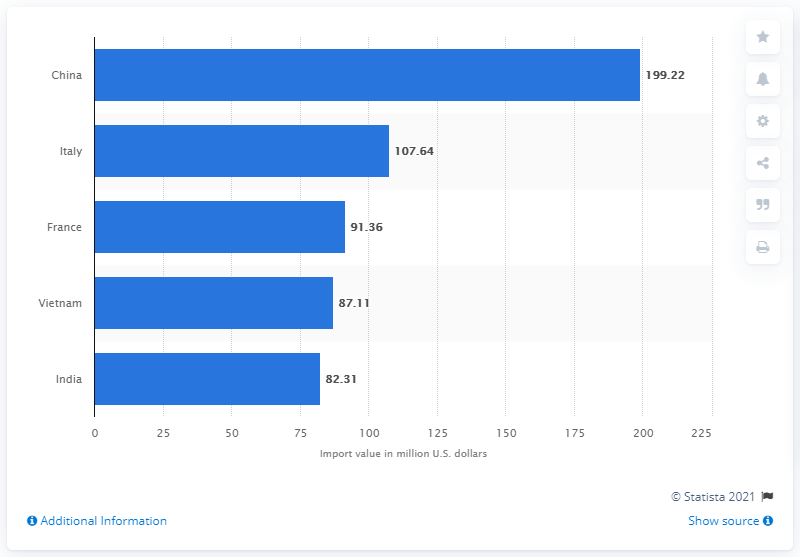List a handful of essential elements in this visual. In 2020, China exported $199.22 billion dollars to the United States. The country that was the leading exporter of personal leather goods to the United States in 2020 was China. In 2020, Italy was the second largest exporter of personal leather goods to the United States. 